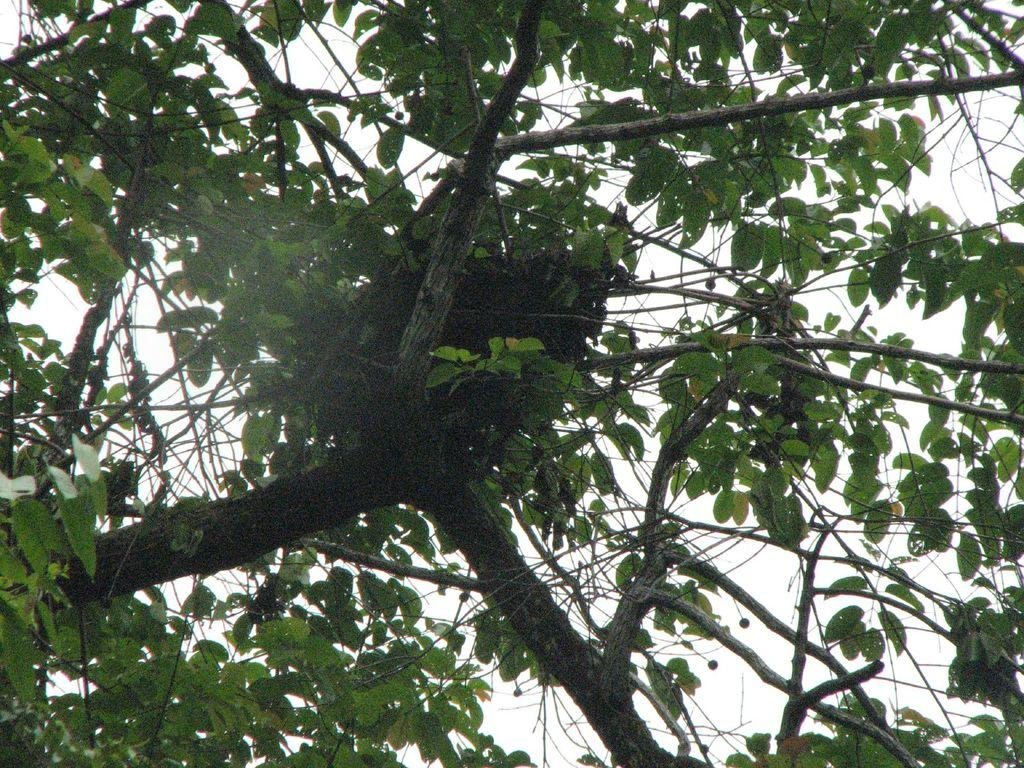What is the main object in the image? There is a tree in the image. What is located on the tree? There is a birds nest on the tree. What can be seen in the background of the image? The sky is visible in the background of the image. What type of plough can be seen in the image? There is no plough present in the image. How many deer are visible in the image? There are no deer present in the image. 